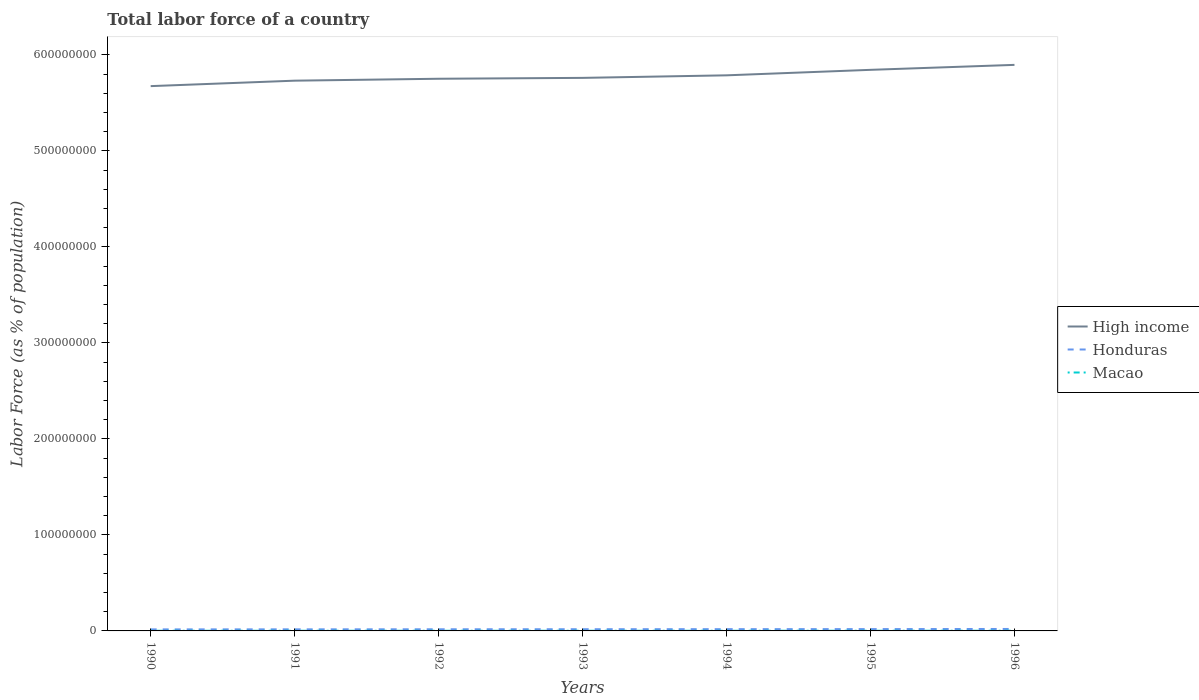How many different coloured lines are there?
Your answer should be very brief. 3. Is the number of lines equal to the number of legend labels?
Make the answer very short. Yes. Across all years, what is the maximum percentage of labor force in High income?
Your response must be concise. 5.67e+08. In which year was the percentage of labor force in Macao maximum?
Give a very brief answer. 1990. What is the total percentage of labor force in Macao in the graph?
Offer a very short reply. -8083. What is the difference between the highest and the second highest percentage of labor force in Honduras?
Provide a succinct answer. 4.51e+05. What is the difference between the highest and the lowest percentage of labor force in Honduras?
Make the answer very short. 3. Is the percentage of labor force in Honduras strictly greater than the percentage of labor force in Macao over the years?
Provide a succinct answer. No. Are the values on the major ticks of Y-axis written in scientific E-notation?
Your answer should be compact. No. How many legend labels are there?
Offer a very short reply. 3. What is the title of the graph?
Offer a terse response. Total labor force of a country. Does "Seychelles" appear as one of the legend labels in the graph?
Make the answer very short. No. What is the label or title of the X-axis?
Offer a very short reply. Years. What is the label or title of the Y-axis?
Offer a very short reply. Labor Force (as % of population). What is the Labor Force (as % of population) of High income in 1990?
Your answer should be very brief. 5.67e+08. What is the Labor Force (as % of population) in Honduras in 1990?
Provide a succinct answer. 1.59e+06. What is the Labor Force (as % of population) of Macao in 1990?
Your answer should be compact. 1.55e+05. What is the Labor Force (as % of population) of High income in 1991?
Ensure brevity in your answer.  5.73e+08. What is the Labor Force (as % of population) in Honduras in 1991?
Your answer should be very brief. 1.64e+06. What is the Labor Force (as % of population) in Macao in 1991?
Give a very brief answer. 1.59e+05. What is the Labor Force (as % of population) of High income in 1992?
Your answer should be compact. 5.75e+08. What is the Labor Force (as % of population) in Honduras in 1992?
Your answer should be very brief. 1.71e+06. What is the Labor Force (as % of population) of Macao in 1992?
Your response must be concise. 1.63e+05. What is the Labor Force (as % of population) of High income in 1993?
Your answer should be very brief. 5.76e+08. What is the Labor Force (as % of population) of Honduras in 1993?
Offer a terse response. 1.77e+06. What is the Labor Force (as % of population) in Macao in 1993?
Ensure brevity in your answer.  1.67e+05. What is the Labor Force (as % of population) in High income in 1994?
Ensure brevity in your answer.  5.79e+08. What is the Labor Force (as % of population) of Honduras in 1994?
Keep it short and to the point. 1.83e+06. What is the Labor Force (as % of population) of Macao in 1994?
Offer a very short reply. 1.70e+05. What is the Labor Force (as % of population) in High income in 1995?
Your response must be concise. 5.84e+08. What is the Labor Force (as % of population) of Honduras in 1995?
Your answer should be compact. 1.89e+06. What is the Labor Force (as % of population) in Macao in 1995?
Provide a succinct answer. 1.77e+05. What is the Labor Force (as % of population) in High income in 1996?
Offer a very short reply. 5.90e+08. What is the Labor Force (as % of population) of Honduras in 1996?
Keep it short and to the point. 2.04e+06. What is the Labor Force (as % of population) in Macao in 1996?
Provide a short and direct response. 2.04e+05. Across all years, what is the maximum Labor Force (as % of population) in High income?
Provide a short and direct response. 5.90e+08. Across all years, what is the maximum Labor Force (as % of population) of Honduras?
Offer a terse response. 2.04e+06. Across all years, what is the maximum Labor Force (as % of population) in Macao?
Provide a succinct answer. 2.04e+05. Across all years, what is the minimum Labor Force (as % of population) in High income?
Your response must be concise. 5.67e+08. Across all years, what is the minimum Labor Force (as % of population) in Honduras?
Offer a very short reply. 1.59e+06. Across all years, what is the minimum Labor Force (as % of population) of Macao?
Ensure brevity in your answer.  1.55e+05. What is the total Labor Force (as % of population) of High income in the graph?
Offer a terse response. 4.04e+09. What is the total Labor Force (as % of population) in Honduras in the graph?
Ensure brevity in your answer.  1.25e+07. What is the total Labor Force (as % of population) of Macao in the graph?
Ensure brevity in your answer.  1.19e+06. What is the difference between the Labor Force (as % of population) of High income in 1990 and that in 1991?
Provide a succinct answer. -5.67e+06. What is the difference between the Labor Force (as % of population) in Honduras in 1990 and that in 1991?
Offer a terse response. -5.05e+04. What is the difference between the Labor Force (as % of population) of Macao in 1990 and that in 1991?
Your answer should be compact. -4042. What is the difference between the Labor Force (as % of population) of High income in 1990 and that in 1992?
Offer a terse response. -7.67e+06. What is the difference between the Labor Force (as % of population) in Honduras in 1990 and that in 1992?
Give a very brief answer. -1.22e+05. What is the difference between the Labor Force (as % of population) in Macao in 1990 and that in 1992?
Provide a short and direct response. -8748. What is the difference between the Labor Force (as % of population) of High income in 1990 and that in 1993?
Provide a succinct answer. -8.59e+06. What is the difference between the Labor Force (as % of population) of Honduras in 1990 and that in 1993?
Give a very brief answer. -1.81e+05. What is the difference between the Labor Force (as % of population) in Macao in 1990 and that in 1993?
Keep it short and to the point. -1.21e+04. What is the difference between the Labor Force (as % of population) in High income in 1990 and that in 1994?
Offer a very short reply. -1.12e+07. What is the difference between the Labor Force (as % of population) in Honduras in 1990 and that in 1994?
Your answer should be compact. -2.41e+05. What is the difference between the Labor Force (as % of population) in Macao in 1990 and that in 1994?
Make the answer very short. -1.49e+04. What is the difference between the Labor Force (as % of population) of High income in 1990 and that in 1995?
Keep it short and to the point. -1.70e+07. What is the difference between the Labor Force (as % of population) in Honduras in 1990 and that in 1995?
Give a very brief answer. -3.03e+05. What is the difference between the Labor Force (as % of population) of Macao in 1990 and that in 1995?
Your answer should be compact. -2.28e+04. What is the difference between the Labor Force (as % of population) in High income in 1990 and that in 1996?
Offer a very short reply. -2.21e+07. What is the difference between the Labor Force (as % of population) of Honduras in 1990 and that in 1996?
Your answer should be compact. -4.51e+05. What is the difference between the Labor Force (as % of population) in Macao in 1990 and that in 1996?
Ensure brevity in your answer.  -4.97e+04. What is the difference between the Labor Force (as % of population) of High income in 1991 and that in 1992?
Your answer should be very brief. -2.00e+06. What is the difference between the Labor Force (as % of population) of Honduras in 1991 and that in 1992?
Offer a terse response. -7.12e+04. What is the difference between the Labor Force (as % of population) in Macao in 1991 and that in 1992?
Ensure brevity in your answer.  -4706. What is the difference between the Labor Force (as % of population) in High income in 1991 and that in 1993?
Give a very brief answer. -2.91e+06. What is the difference between the Labor Force (as % of population) of Honduras in 1991 and that in 1993?
Ensure brevity in your answer.  -1.30e+05. What is the difference between the Labor Force (as % of population) of Macao in 1991 and that in 1993?
Your answer should be compact. -8083. What is the difference between the Labor Force (as % of population) in High income in 1991 and that in 1994?
Your answer should be compact. -5.56e+06. What is the difference between the Labor Force (as % of population) of Honduras in 1991 and that in 1994?
Give a very brief answer. -1.90e+05. What is the difference between the Labor Force (as % of population) of Macao in 1991 and that in 1994?
Provide a short and direct response. -1.08e+04. What is the difference between the Labor Force (as % of population) in High income in 1991 and that in 1995?
Ensure brevity in your answer.  -1.13e+07. What is the difference between the Labor Force (as % of population) of Honduras in 1991 and that in 1995?
Provide a short and direct response. -2.52e+05. What is the difference between the Labor Force (as % of population) of Macao in 1991 and that in 1995?
Give a very brief answer. -1.87e+04. What is the difference between the Labor Force (as % of population) of High income in 1991 and that in 1996?
Provide a short and direct response. -1.65e+07. What is the difference between the Labor Force (as % of population) of Honduras in 1991 and that in 1996?
Provide a succinct answer. -4.00e+05. What is the difference between the Labor Force (as % of population) in Macao in 1991 and that in 1996?
Offer a very short reply. -4.56e+04. What is the difference between the Labor Force (as % of population) in High income in 1992 and that in 1993?
Ensure brevity in your answer.  -9.15e+05. What is the difference between the Labor Force (as % of population) of Honduras in 1992 and that in 1993?
Give a very brief answer. -5.88e+04. What is the difference between the Labor Force (as % of population) in Macao in 1992 and that in 1993?
Provide a succinct answer. -3377. What is the difference between the Labor Force (as % of population) in High income in 1992 and that in 1994?
Provide a short and direct response. -3.57e+06. What is the difference between the Labor Force (as % of population) in Honduras in 1992 and that in 1994?
Offer a very short reply. -1.19e+05. What is the difference between the Labor Force (as % of population) in Macao in 1992 and that in 1994?
Your response must be concise. -6110. What is the difference between the Labor Force (as % of population) of High income in 1992 and that in 1995?
Provide a short and direct response. -9.29e+06. What is the difference between the Labor Force (as % of population) in Honduras in 1992 and that in 1995?
Keep it short and to the point. -1.81e+05. What is the difference between the Labor Force (as % of population) in Macao in 1992 and that in 1995?
Make the answer very short. -1.40e+04. What is the difference between the Labor Force (as % of population) of High income in 1992 and that in 1996?
Your answer should be compact. -1.45e+07. What is the difference between the Labor Force (as % of population) of Honduras in 1992 and that in 1996?
Offer a terse response. -3.29e+05. What is the difference between the Labor Force (as % of population) of Macao in 1992 and that in 1996?
Provide a short and direct response. -4.09e+04. What is the difference between the Labor Force (as % of population) of High income in 1993 and that in 1994?
Give a very brief answer. -2.65e+06. What is the difference between the Labor Force (as % of population) in Honduras in 1993 and that in 1994?
Your response must be concise. -6.03e+04. What is the difference between the Labor Force (as % of population) of Macao in 1993 and that in 1994?
Make the answer very short. -2733. What is the difference between the Labor Force (as % of population) of High income in 1993 and that in 1995?
Ensure brevity in your answer.  -8.38e+06. What is the difference between the Labor Force (as % of population) in Honduras in 1993 and that in 1995?
Offer a very short reply. -1.22e+05. What is the difference between the Labor Force (as % of population) of Macao in 1993 and that in 1995?
Make the answer very short. -1.07e+04. What is the difference between the Labor Force (as % of population) of High income in 1993 and that in 1996?
Make the answer very short. -1.35e+07. What is the difference between the Labor Force (as % of population) of Honduras in 1993 and that in 1996?
Provide a short and direct response. -2.70e+05. What is the difference between the Labor Force (as % of population) of Macao in 1993 and that in 1996?
Provide a succinct answer. -3.76e+04. What is the difference between the Labor Force (as % of population) in High income in 1994 and that in 1995?
Give a very brief answer. -5.73e+06. What is the difference between the Labor Force (as % of population) of Honduras in 1994 and that in 1995?
Ensure brevity in your answer.  -6.20e+04. What is the difference between the Labor Force (as % of population) in Macao in 1994 and that in 1995?
Make the answer very short. -7920. What is the difference between the Labor Force (as % of population) in High income in 1994 and that in 1996?
Provide a succinct answer. -1.09e+07. What is the difference between the Labor Force (as % of population) of Honduras in 1994 and that in 1996?
Offer a very short reply. -2.10e+05. What is the difference between the Labor Force (as % of population) of Macao in 1994 and that in 1996?
Ensure brevity in your answer.  -3.48e+04. What is the difference between the Labor Force (as % of population) of High income in 1995 and that in 1996?
Offer a very short reply. -5.17e+06. What is the difference between the Labor Force (as % of population) of Honduras in 1995 and that in 1996?
Make the answer very short. -1.48e+05. What is the difference between the Labor Force (as % of population) in Macao in 1995 and that in 1996?
Your answer should be very brief. -2.69e+04. What is the difference between the Labor Force (as % of population) in High income in 1990 and the Labor Force (as % of population) in Honduras in 1991?
Your answer should be compact. 5.66e+08. What is the difference between the Labor Force (as % of population) of High income in 1990 and the Labor Force (as % of population) of Macao in 1991?
Provide a succinct answer. 5.67e+08. What is the difference between the Labor Force (as % of population) of Honduras in 1990 and the Labor Force (as % of population) of Macao in 1991?
Offer a very short reply. 1.43e+06. What is the difference between the Labor Force (as % of population) of High income in 1990 and the Labor Force (as % of population) of Honduras in 1992?
Offer a very short reply. 5.66e+08. What is the difference between the Labor Force (as % of population) in High income in 1990 and the Labor Force (as % of population) in Macao in 1992?
Ensure brevity in your answer.  5.67e+08. What is the difference between the Labor Force (as % of population) in Honduras in 1990 and the Labor Force (as % of population) in Macao in 1992?
Give a very brief answer. 1.43e+06. What is the difference between the Labor Force (as % of population) of High income in 1990 and the Labor Force (as % of population) of Honduras in 1993?
Offer a very short reply. 5.66e+08. What is the difference between the Labor Force (as % of population) in High income in 1990 and the Labor Force (as % of population) in Macao in 1993?
Your response must be concise. 5.67e+08. What is the difference between the Labor Force (as % of population) in Honduras in 1990 and the Labor Force (as % of population) in Macao in 1993?
Offer a very short reply. 1.42e+06. What is the difference between the Labor Force (as % of population) of High income in 1990 and the Labor Force (as % of population) of Honduras in 1994?
Provide a short and direct response. 5.66e+08. What is the difference between the Labor Force (as % of population) of High income in 1990 and the Labor Force (as % of population) of Macao in 1994?
Your response must be concise. 5.67e+08. What is the difference between the Labor Force (as % of population) of Honduras in 1990 and the Labor Force (as % of population) of Macao in 1994?
Give a very brief answer. 1.42e+06. What is the difference between the Labor Force (as % of population) of High income in 1990 and the Labor Force (as % of population) of Honduras in 1995?
Your answer should be compact. 5.66e+08. What is the difference between the Labor Force (as % of population) in High income in 1990 and the Labor Force (as % of population) in Macao in 1995?
Offer a terse response. 5.67e+08. What is the difference between the Labor Force (as % of population) of Honduras in 1990 and the Labor Force (as % of population) of Macao in 1995?
Offer a very short reply. 1.41e+06. What is the difference between the Labor Force (as % of population) of High income in 1990 and the Labor Force (as % of population) of Honduras in 1996?
Give a very brief answer. 5.65e+08. What is the difference between the Labor Force (as % of population) in High income in 1990 and the Labor Force (as % of population) in Macao in 1996?
Provide a succinct answer. 5.67e+08. What is the difference between the Labor Force (as % of population) of Honduras in 1990 and the Labor Force (as % of population) of Macao in 1996?
Make the answer very short. 1.39e+06. What is the difference between the Labor Force (as % of population) of High income in 1991 and the Labor Force (as % of population) of Honduras in 1992?
Ensure brevity in your answer.  5.71e+08. What is the difference between the Labor Force (as % of population) of High income in 1991 and the Labor Force (as % of population) of Macao in 1992?
Provide a succinct answer. 5.73e+08. What is the difference between the Labor Force (as % of population) of Honduras in 1991 and the Labor Force (as % of population) of Macao in 1992?
Ensure brevity in your answer.  1.48e+06. What is the difference between the Labor Force (as % of population) of High income in 1991 and the Labor Force (as % of population) of Honduras in 1993?
Your answer should be compact. 5.71e+08. What is the difference between the Labor Force (as % of population) in High income in 1991 and the Labor Force (as % of population) in Macao in 1993?
Offer a terse response. 5.73e+08. What is the difference between the Labor Force (as % of population) of Honduras in 1991 and the Labor Force (as % of population) of Macao in 1993?
Give a very brief answer. 1.48e+06. What is the difference between the Labor Force (as % of population) in High income in 1991 and the Labor Force (as % of population) in Honduras in 1994?
Offer a very short reply. 5.71e+08. What is the difference between the Labor Force (as % of population) of High income in 1991 and the Labor Force (as % of population) of Macao in 1994?
Offer a very short reply. 5.73e+08. What is the difference between the Labor Force (as % of population) of Honduras in 1991 and the Labor Force (as % of population) of Macao in 1994?
Offer a very short reply. 1.47e+06. What is the difference between the Labor Force (as % of population) in High income in 1991 and the Labor Force (as % of population) in Honduras in 1995?
Your response must be concise. 5.71e+08. What is the difference between the Labor Force (as % of population) in High income in 1991 and the Labor Force (as % of population) in Macao in 1995?
Make the answer very short. 5.73e+08. What is the difference between the Labor Force (as % of population) in Honduras in 1991 and the Labor Force (as % of population) in Macao in 1995?
Provide a short and direct response. 1.46e+06. What is the difference between the Labor Force (as % of population) in High income in 1991 and the Labor Force (as % of population) in Honduras in 1996?
Ensure brevity in your answer.  5.71e+08. What is the difference between the Labor Force (as % of population) of High income in 1991 and the Labor Force (as % of population) of Macao in 1996?
Offer a very short reply. 5.73e+08. What is the difference between the Labor Force (as % of population) of Honduras in 1991 and the Labor Force (as % of population) of Macao in 1996?
Provide a short and direct response. 1.44e+06. What is the difference between the Labor Force (as % of population) in High income in 1992 and the Labor Force (as % of population) in Honduras in 1993?
Your answer should be very brief. 5.73e+08. What is the difference between the Labor Force (as % of population) in High income in 1992 and the Labor Force (as % of population) in Macao in 1993?
Keep it short and to the point. 5.75e+08. What is the difference between the Labor Force (as % of population) in Honduras in 1992 and the Labor Force (as % of population) in Macao in 1993?
Give a very brief answer. 1.55e+06. What is the difference between the Labor Force (as % of population) of High income in 1992 and the Labor Force (as % of population) of Honduras in 1994?
Your answer should be compact. 5.73e+08. What is the difference between the Labor Force (as % of population) of High income in 1992 and the Labor Force (as % of population) of Macao in 1994?
Your answer should be compact. 5.75e+08. What is the difference between the Labor Force (as % of population) in Honduras in 1992 and the Labor Force (as % of population) in Macao in 1994?
Your response must be concise. 1.54e+06. What is the difference between the Labor Force (as % of population) in High income in 1992 and the Labor Force (as % of population) in Honduras in 1995?
Your answer should be compact. 5.73e+08. What is the difference between the Labor Force (as % of population) of High income in 1992 and the Labor Force (as % of population) of Macao in 1995?
Give a very brief answer. 5.75e+08. What is the difference between the Labor Force (as % of population) in Honduras in 1992 and the Labor Force (as % of population) in Macao in 1995?
Your response must be concise. 1.54e+06. What is the difference between the Labor Force (as % of population) of High income in 1992 and the Labor Force (as % of population) of Honduras in 1996?
Provide a succinct answer. 5.73e+08. What is the difference between the Labor Force (as % of population) of High income in 1992 and the Labor Force (as % of population) of Macao in 1996?
Your answer should be compact. 5.75e+08. What is the difference between the Labor Force (as % of population) in Honduras in 1992 and the Labor Force (as % of population) in Macao in 1996?
Your response must be concise. 1.51e+06. What is the difference between the Labor Force (as % of population) of High income in 1993 and the Labor Force (as % of population) of Honduras in 1994?
Your answer should be compact. 5.74e+08. What is the difference between the Labor Force (as % of population) of High income in 1993 and the Labor Force (as % of population) of Macao in 1994?
Keep it short and to the point. 5.76e+08. What is the difference between the Labor Force (as % of population) of Honduras in 1993 and the Labor Force (as % of population) of Macao in 1994?
Ensure brevity in your answer.  1.60e+06. What is the difference between the Labor Force (as % of population) in High income in 1993 and the Labor Force (as % of population) in Honduras in 1995?
Make the answer very short. 5.74e+08. What is the difference between the Labor Force (as % of population) of High income in 1993 and the Labor Force (as % of population) of Macao in 1995?
Give a very brief answer. 5.76e+08. What is the difference between the Labor Force (as % of population) of Honduras in 1993 and the Labor Force (as % of population) of Macao in 1995?
Your answer should be compact. 1.59e+06. What is the difference between the Labor Force (as % of population) in High income in 1993 and the Labor Force (as % of population) in Honduras in 1996?
Make the answer very short. 5.74e+08. What is the difference between the Labor Force (as % of population) of High income in 1993 and the Labor Force (as % of population) of Macao in 1996?
Make the answer very short. 5.76e+08. What is the difference between the Labor Force (as % of population) in Honduras in 1993 and the Labor Force (as % of population) in Macao in 1996?
Offer a terse response. 1.57e+06. What is the difference between the Labor Force (as % of population) in High income in 1994 and the Labor Force (as % of population) in Honduras in 1995?
Your answer should be very brief. 5.77e+08. What is the difference between the Labor Force (as % of population) of High income in 1994 and the Labor Force (as % of population) of Macao in 1995?
Your answer should be compact. 5.78e+08. What is the difference between the Labor Force (as % of population) of Honduras in 1994 and the Labor Force (as % of population) of Macao in 1995?
Offer a very short reply. 1.65e+06. What is the difference between the Labor Force (as % of population) of High income in 1994 and the Labor Force (as % of population) of Honduras in 1996?
Provide a short and direct response. 5.77e+08. What is the difference between the Labor Force (as % of population) in High income in 1994 and the Labor Force (as % of population) in Macao in 1996?
Your answer should be very brief. 5.78e+08. What is the difference between the Labor Force (as % of population) of Honduras in 1994 and the Labor Force (as % of population) of Macao in 1996?
Provide a short and direct response. 1.63e+06. What is the difference between the Labor Force (as % of population) of High income in 1995 and the Labor Force (as % of population) of Honduras in 1996?
Your answer should be very brief. 5.82e+08. What is the difference between the Labor Force (as % of population) in High income in 1995 and the Labor Force (as % of population) in Macao in 1996?
Offer a terse response. 5.84e+08. What is the difference between the Labor Force (as % of population) of Honduras in 1995 and the Labor Force (as % of population) of Macao in 1996?
Your answer should be compact. 1.69e+06. What is the average Labor Force (as % of population) in High income per year?
Offer a very short reply. 5.78e+08. What is the average Labor Force (as % of population) in Honduras per year?
Ensure brevity in your answer.  1.78e+06. What is the average Labor Force (as % of population) in Macao per year?
Offer a terse response. 1.71e+05. In the year 1990, what is the difference between the Labor Force (as % of population) of High income and Labor Force (as % of population) of Honduras?
Provide a succinct answer. 5.66e+08. In the year 1990, what is the difference between the Labor Force (as % of population) in High income and Labor Force (as % of population) in Macao?
Offer a very short reply. 5.67e+08. In the year 1990, what is the difference between the Labor Force (as % of population) of Honduras and Labor Force (as % of population) of Macao?
Offer a very short reply. 1.44e+06. In the year 1991, what is the difference between the Labor Force (as % of population) of High income and Labor Force (as % of population) of Honduras?
Provide a succinct answer. 5.71e+08. In the year 1991, what is the difference between the Labor Force (as % of population) of High income and Labor Force (as % of population) of Macao?
Your answer should be compact. 5.73e+08. In the year 1991, what is the difference between the Labor Force (as % of population) in Honduras and Labor Force (as % of population) in Macao?
Your answer should be very brief. 1.48e+06. In the year 1992, what is the difference between the Labor Force (as % of population) of High income and Labor Force (as % of population) of Honduras?
Ensure brevity in your answer.  5.73e+08. In the year 1992, what is the difference between the Labor Force (as % of population) of High income and Labor Force (as % of population) of Macao?
Give a very brief answer. 5.75e+08. In the year 1992, what is the difference between the Labor Force (as % of population) of Honduras and Labor Force (as % of population) of Macao?
Offer a very short reply. 1.55e+06. In the year 1993, what is the difference between the Labor Force (as % of population) in High income and Labor Force (as % of population) in Honduras?
Ensure brevity in your answer.  5.74e+08. In the year 1993, what is the difference between the Labor Force (as % of population) in High income and Labor Force (as % of population) in Macao?
Provide a succinct answer. 5.76e+08. In the year 1993, what is the difference between the Labor Force (as % of population) in Honduras and Labor Force (as % of population) in Macao?
Your response must be concise. 1.61e+06. In the year 1994, what is the difference between the Labor Force (as % of population) in High income and Labor Force (as % of population) in Honduras?
Provide a succinct answer. 5.77e+08. In the year 1994, what is the difference between the Labor Force (as % of population) of High income and Labor Force (as % of population) of Macao?
Make the answer very short. 5.79e+08. In the year 1994, what is the difference between the Labor Force (as % of population) of Honduras and Labor Force (as % of population) of Macao?
Provide a succinct answer. 1.66e+06. In the year 1995, what is the difference between the Labor Force (as % of population) in High income and Labor Force (as % of population) in Honduras?
Ensure brevity in your answer.  5.83e+08. In the year 1995, what is the difference between the Labor Force (as % of population) of High income and Labor Force (as % of population) of Macao?
Provide a succinct answer. 5.84e+08. In the year 1995, what is the difference between the Labor Force (as % of population) of Honduras and Labor Force (as % of population) of Macao?
Give a very brief answer. 1.72e+06. In the year 1996, what is the difference between the Labor Force (as % of population) of High income and Labor Force (as % of population) of Honduras?
Your answer should be compact. 5.88e+08. In the year 1996, what is the difference between the Labor Force (as % of population) in High income and Labor Force (as % of population) in Macao?
Offer a very short reply. 5.89e+08. In the year 1996, what is the difference between the Labor Force (as % of population) in Honduras and Labor Force (as % of population) in Macao?
Give a very brief answer. 1.84e+06. What is the ratio of the Labor Force (as % of population) of High income in 1990 to that in 1991?
Provide a succinct answer. 0.99. What is the ratio of the Labor Force (as % of population) of Honduras in 1990 to that in 1991?
Provide a succinct answer. 0.97. What is the ratio of the Labor Force (as % of population) of Macao in 1990 to that in 1991?
Provide a succinct answer. 0.97. What is the ratio of the Labor Force (as % of population) of High income in 1990 to that in 1992?
Offer a terse response. 0.99. What is the ratio of the Labor Force (as % of population) of Honduras in 1990 to that in 1992?
Keep it short and to the point. 0.93. What is the ratio of the Labor Force (as % of population) in Macao in 1990 to that in 1992?
Your response must be concise. 0.95. What is the ratio of the Labor Force (as % of population) of High income in 1990 to that in 1993?
Provide a succinct answer. 0.99. What is the ratio of the Labor Force (as % of population) in Honduras in 1990 to that in 1993?
Give a very brief answer. 0.9. What is the ratio of the Labor Force (as % of population) of Macao in 1990 to that in 1993?
Your response must be concise. 0.93. What is the ratio of the Labor Force (as % of population) in High income in 1990 to that in 1994?
Give a very brief answer. 0.98. What is the ratio of the Labor Force (as % of population) in Honduras in 1990 to that in 1994?
Provide a short and direct response. 0.87. What is the ratio of the Labor Force (as % of population) in Macao in 1990 to that in 1994?
Keep it short and to the point. 0.91. What is the ratio of the Labor Force (as % of population) of High income in 1990 to that in 1995?
Your answer should be very brief. 0.97. What is the ratio of the Labor Force (as % of population) in Honduras in 1990 to that in 1995?
Ensure brevity in your answer.  0.84. What is the ratio of the Labor Force (as % of population) in Macao in 1990 to that in 1995?
Provide a short and direct response. 0.87. What is the ratio of the Labor Force (as % of population) in High income in 1990 to that in 1996?
Provide a succinct answer. 0.96. What is the ratio of the Labor Force (as % of population) in Honduras in 1990 to that in 1996?
Your response must be concise. 0.78. What is the ratio of the Labor Force (as % of population) of Macao in 1990 to that in 1996?
Ensure brevity in your answer.  0.76. What is the ratio of the Labor Force (as % of population) in Honduras in 1991 to that in 1992?
Ensure brevity in your answer.  0.96. What is the ratio of the Labor Force (as % of population) of Macao in 1991 to that in 1992?
Make the answer very short. 0.97. What is the ratio of the Labor Force (as % of population) in Honduras in 1991 to that in 1993?
Your response must be concise. 0.93. What is the ratio of the Labor Force (as % of population) in Macao in 1991 to that in 1993?
Your answer should be compact. 0.95. What is the ratio of the Labor Force (as % of population) in Honduras in 1991 to that in 1994?
Provide a succinct answer. 0.9. What is the ratio of the Labor Force (as % of population) of Macao in 1991 to that in 1994?
Offer a terse response. 0.94. What is the ratio of the Labor Force (as % of population) of High income in 1991 to that in 1995?
Provide a succinct answer. 0.98. What is the ratio of the Labor Force (as % of population) in Honduras in 1991 to that in 1995?
Your answer should be very brief. 0.87. What is the ratio of the Labor Force (as % of population) in Macao in 1991 to that in 1995?
Your response must be concise. 0.89. What is the ratio of the Labor Force (as % of population) of High income in 1991 to that in 1996?
Make the answer very short. 0.97. What is the ratio of the Labor Force (as % of population) in Honduras in 1991 to that in 1996?
Make the answer very short. 0.8. What is the ratio of the Labor Force (as % of population) of Macao in 1991 to that in 1996?
Offer a terse response. 0.78. What is the ratio of the Labor Force (as % of population) of Honduras in 1992 to that in 1993?
Provide a short and direct response. 0.97. What is the ratio of the Labor Force (as % of population) in Macao in 1992 to that in 1993?
Keep it short and to the point. 0.98. What is the ratio of the Labor Force (as % of population) in High income in 1992 to that in 1994?
Your answer should be compact. 0.99. What is the ratio of the Labor Force (as % of population) of Honduras in 1992 to that in 1994?
Give a very brief answer. 0.94. What is the ratio of the Labor Force (as % of population) in High income in 1992 to that in 1995?
Provide a succinct answer. 0.98. What is the ratio of the Labor Force (as % of population) of Honduras in 1992 to that in 1995?
Give a very brief answer. 0.9. What is the ratio of the Labor Force (as % of population) in Macao in 1992 to that in 1995?
Ensure brevity in your answer.  0.92. What is the ratio of the Labor Force (as % of population) in High income in 1992 to that in 1996?
Offer a very short reply. 0.98. What is the ratio of the Labor Force (as % of population) of Honduras in 1992 to that in 1996?
Your answer should be very brief. 0.84. What is the ratio of the Labor Force (as % of population) of Macao in 1992 to that in 1996?
Provide a short and direct response. 0.8. What is the ratio of the Labor Force (as % of population) in High income in 1993 to that in 1994?
Provide a succinct answer. 1. What is the ratio of the Labor Force (as % of population) of Honduras in 1993 to that in 1994?
Ensure brevity in your answer.  0.97. What is the ratio of the Labor Force (as % of population) of Macao in 1993 to that in 1994?
Ensure brevity in your answer.  0.98. What is the ratio of the Labor Force (as % of population) of High income in 1993 to that in 1995?
Make the answer very short. 0.99. What is the ratio of the Labor Force (as % of population) in Honduras in 1993 to that in 1995?
Provide a short and direct response. 0.94. What is the ratio of the Labor Force (as % of population) of High income in 1993 to that in 1996?
Give a very brief answer. 0.98. What is the ratio of the Labor Force (as % of population) in Honduras in 1993 to that in 1996?
Give a very brief answer. 0.87. What is the ratio of the Labor Force (as % of population) of Macao in 1993 to that in 1996?
Keep it short and to the point. 0.82. What is the ratio of the Labor Force (as % of population) in High income in 1994 to that in 1995?
Provide a short and direct response. 0.99. What is the ratio of the Labor Force (as % of population) in Honduras in 1994 to that in 1995?
Your answer should be compact. 0.97. What is the ratio of the Labor Force (as % of population) in Macao in 1994 to that in 1995?
Provide a short and direct response. 0.96. What is the ratio of the Labor Force (as % of population) in High income in 1994 to that in 1996?
Provide a short and direct response. 0.98. What is the ratio of the Labor Force (as % of population) in Honduras in 1994 to that in 1996?
Give a very brief answer. 0.9. What is the ratio of the Labor Force (as % of population) of Macao in 1994 to that in 1996?
Your answer should be very brief. 0.83. What is the ratio of the Labor Force (as % of population) in Honduras in 1995 to that in 1996?
Your answer should be compact. 0.93. What is the ratio of the Labor Force (as % of population) in Macao in 1995 to that in 1996?
Provide a short and direct response. 0.87. What is the difference between the highest and the second highest Labor Force (as % of population) of High income?
Provide a succinct answer. 5.17e+06. What is the difference between the highest and the second highest Labor Force (as % of population) in Honduras?
Ensure brevity in your answer.  1.48e+05. What is the difference between the highest and the second highest Labor Force (as % of population) in Macao?
Offer a very short reply. 2.69e+04. What is the difference between the highest and the lowest Labor Force (as % of population) of High income?
Provide a short and direct response. 2.21e+07. What is the difference between the highest and the lowest Labor Force (as % of population) of Honduras?
Make the answer very short. 4.51e+05. What is the difference between the highest and the lowest Labor Force (as % of population) in Macao?
Offer a terse response. 4.97e+04. 